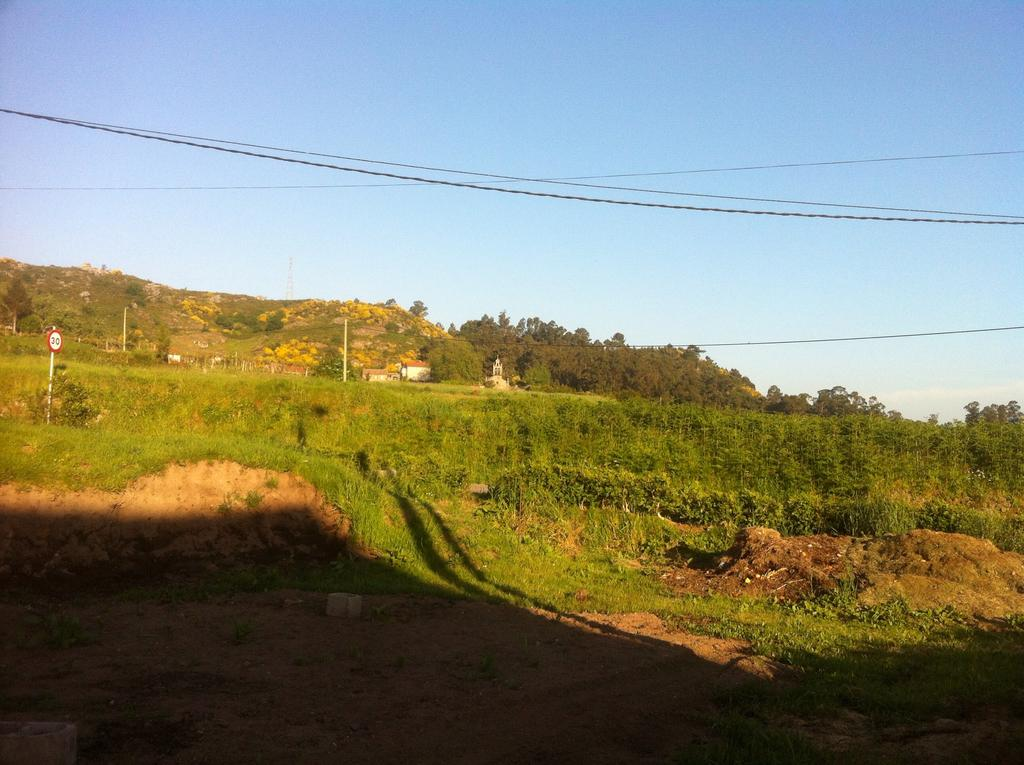What type of ground cover is visible in the image? There is grass on the ground in the image. What can be seen in the distance in the image? There are trees, mountains, and the sky visible in the background of the image. What is the smell of the grass in the image? The image does not provide information about the smell of the grass, so it cannot be determined from the image. 